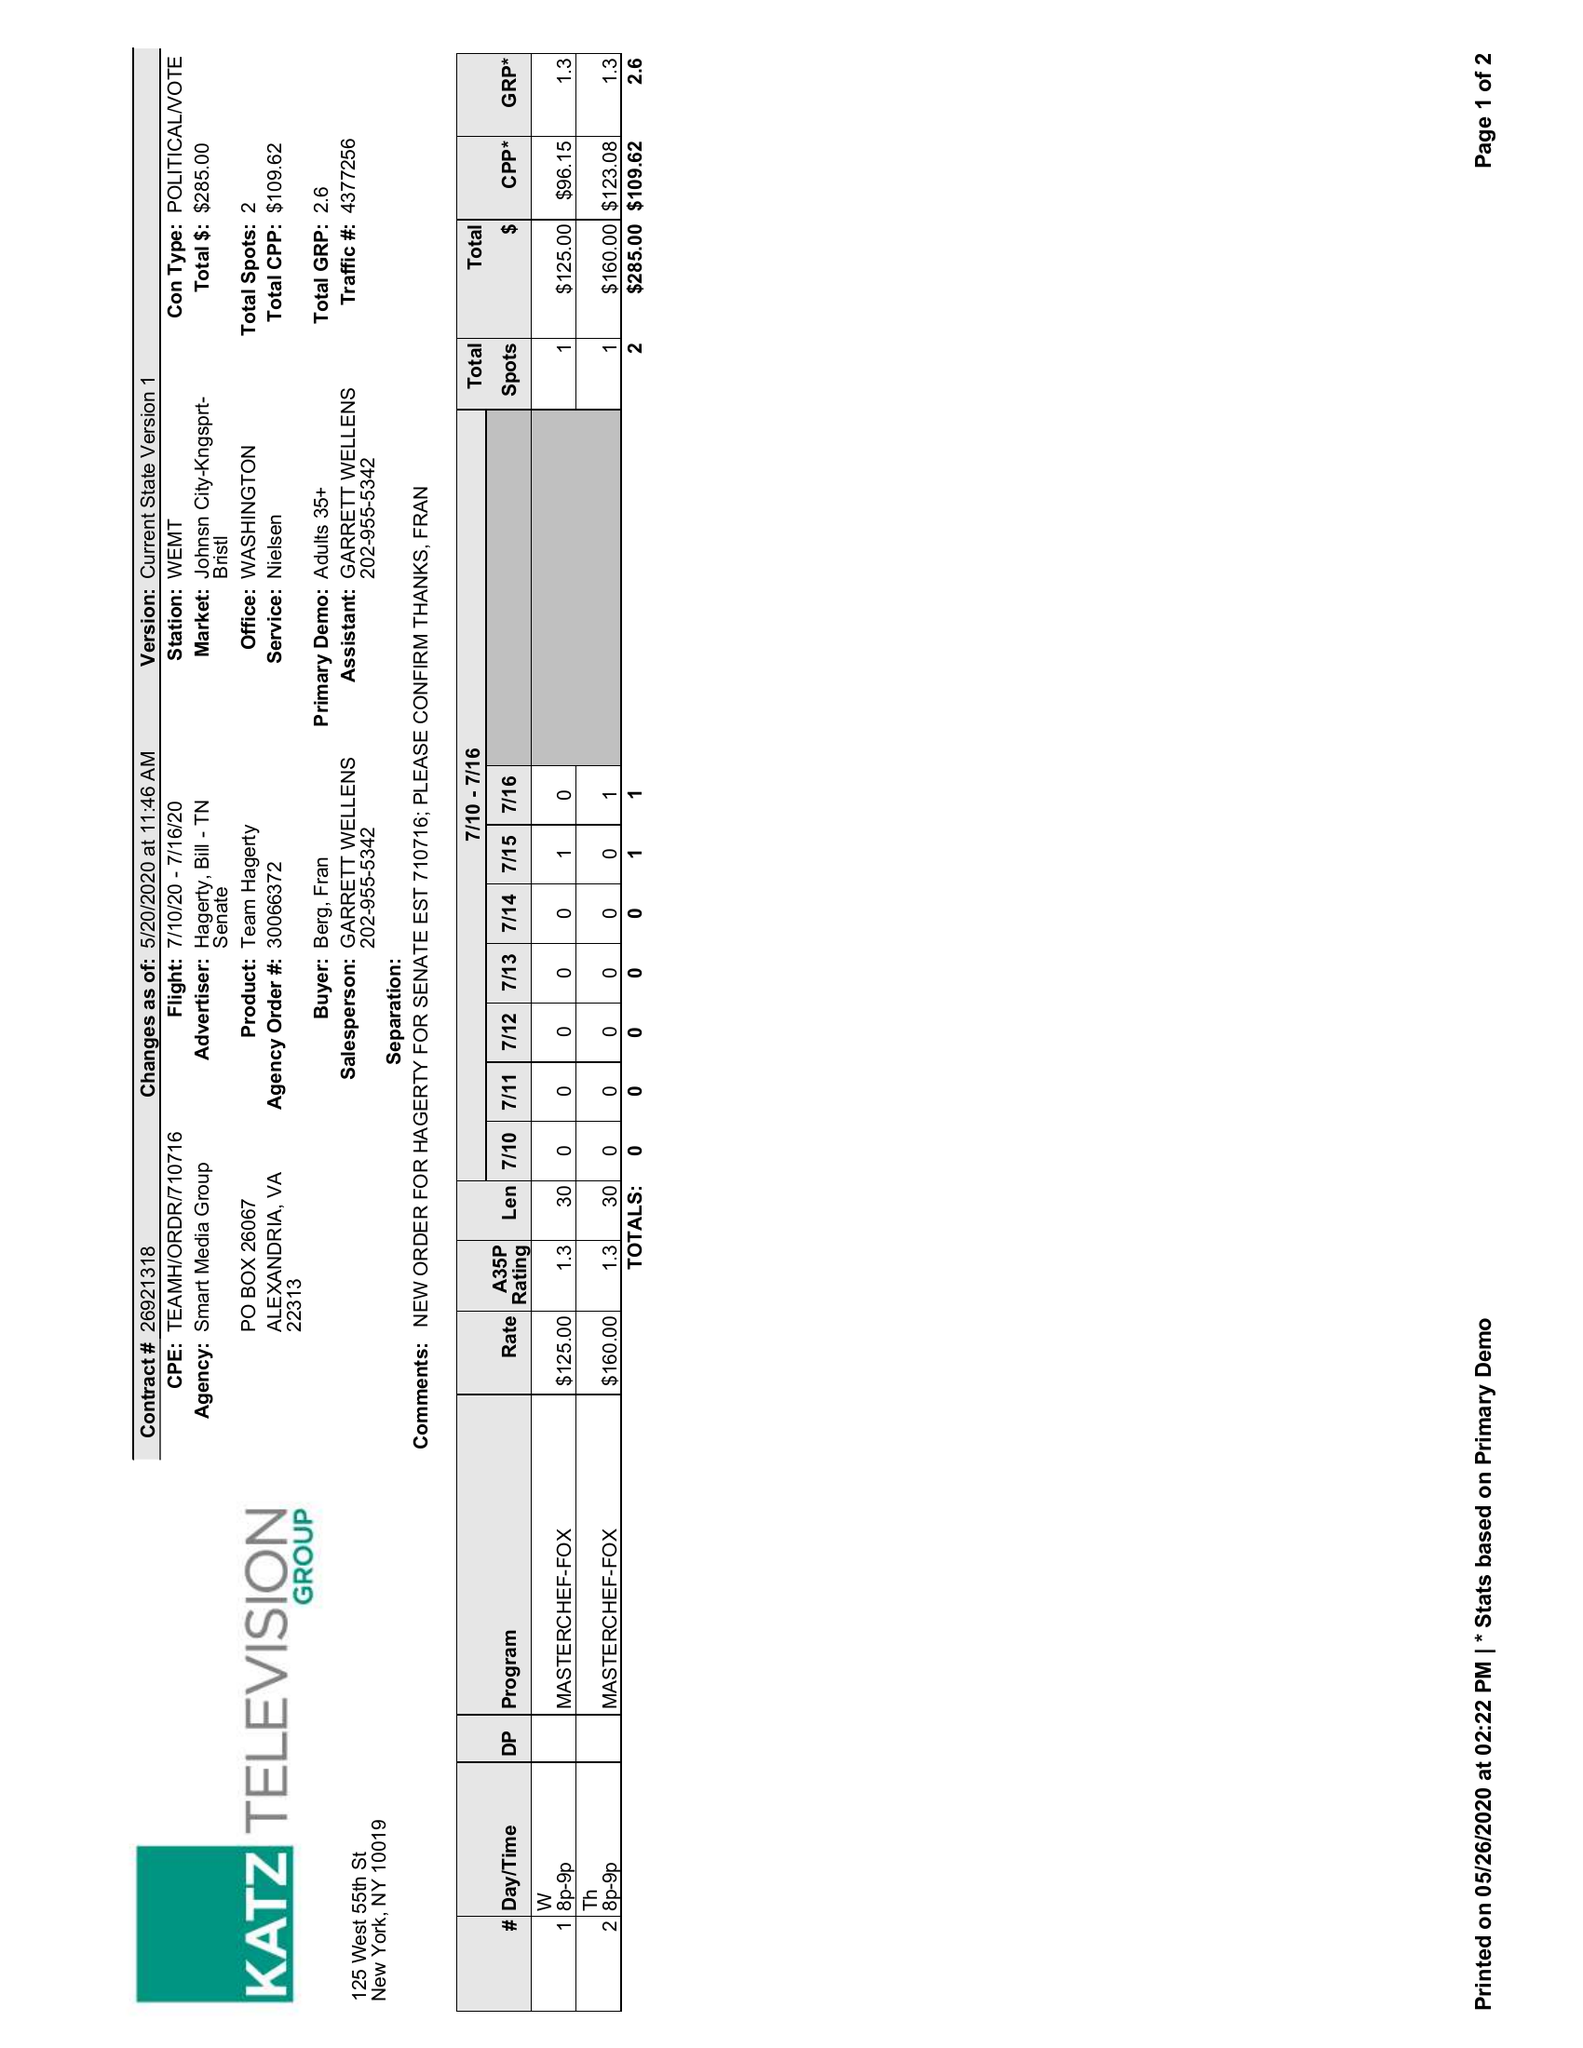What is the value for the gross_amount?
Answer the question using a single word or phrase. 285.00 